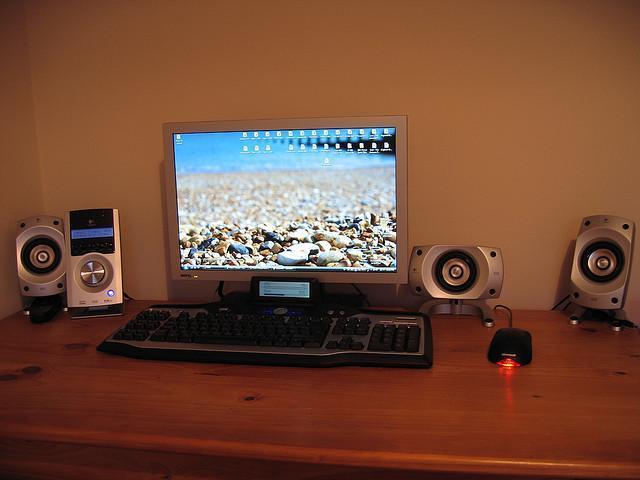How many mice are in this photo?
Give a very brief answer. 1. How many monitors are on top of the desk?
Give a very brief answer. 1. How many orange pillows in the image?
Give a very brief answer. 0. 